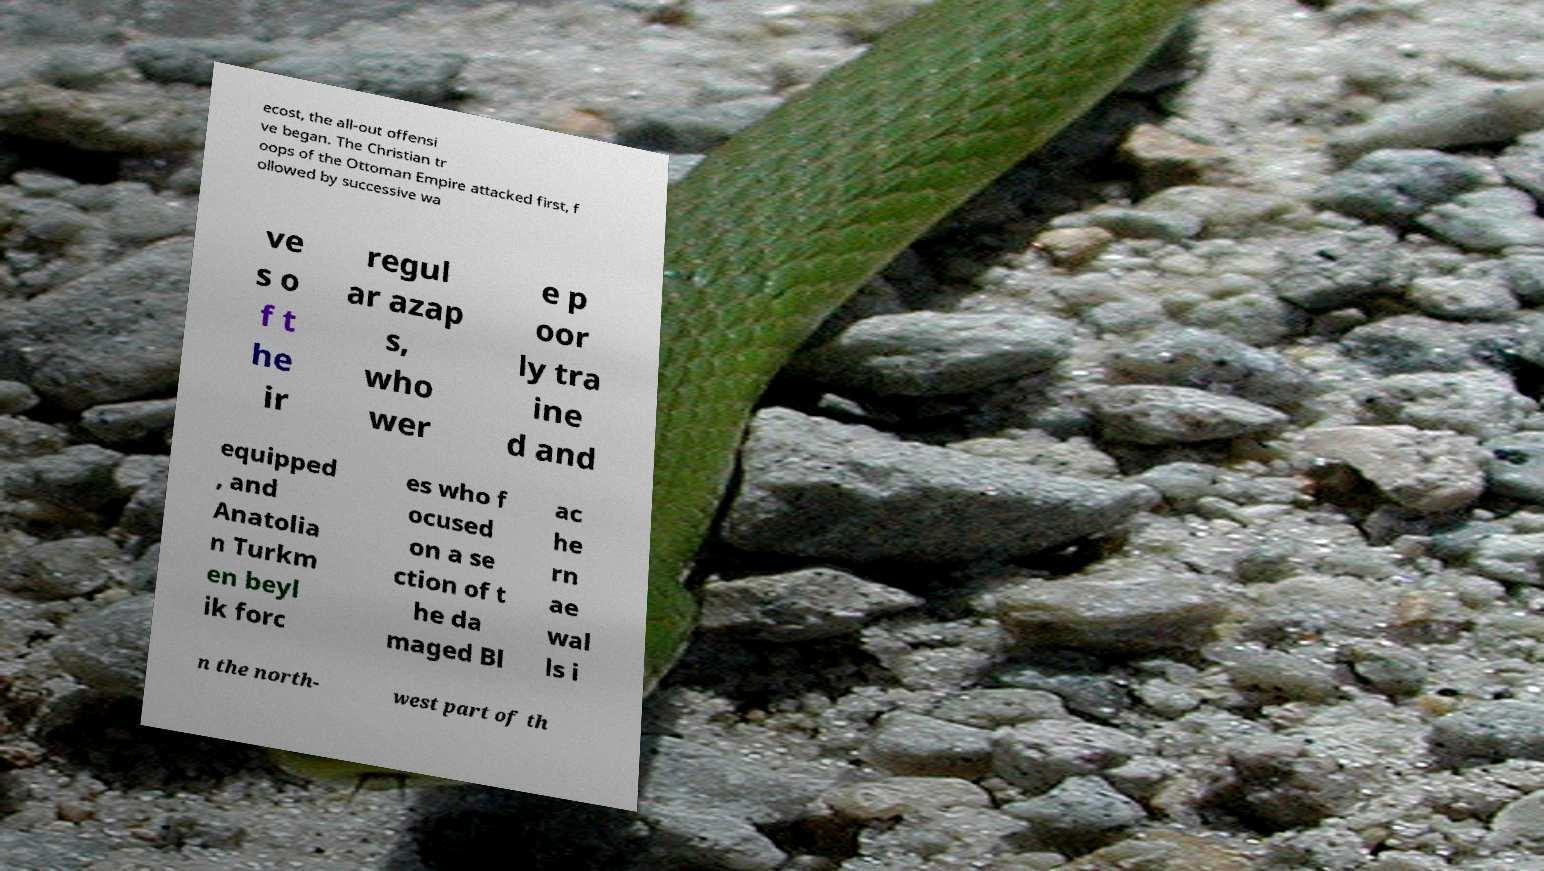Could you assist in decoding the text presented in this image and type it out clearly? ecost, the all-out offensi ve began. The Christian tr oops of the Ottoman Empire attacked first, f ollowed by successive wa ve s o f t he ir regul ar azap s, who wer e p oor ly tra ine d and equipped , and Anatolia n Turkm en beyl ik forc es who f ocused on a se ction of t he da maged Bl ac he rn ae wal ls i n the north- west part of th 